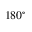Convert formula to latex. <formula><loc_0><loc_0><loc_500><loc_500>1 8 0 ^ { \circ }</formula> 